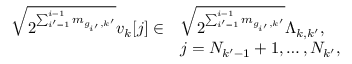Convert formula to latex. <formula><loc_0><loc_0><loc_500><loc_500>\begin{array} { r l } { \sqrt { 2 ^ { \sum _ { i ^ { \prime } = 1 } ^ { i - 1 } m _ { g _ { i ^ { \prime } } , k ^ { \prime } } } } v _ { k } [ j ] \in } & { \sqrt { 2 ^ { \sum _ { i ^ { \prime } = 1 } ^ { i - 1 } m _ { g _ { i ^ { \prime } } , k ^ { \prime } } } } \Lambda _ { k , k ^ { \prime } } , } \\ & { j = N _ { k ^ { \prime } - 1 } + 1 , \dots , N _ { k ^ { \prime } } , } \end{array}</formula> 